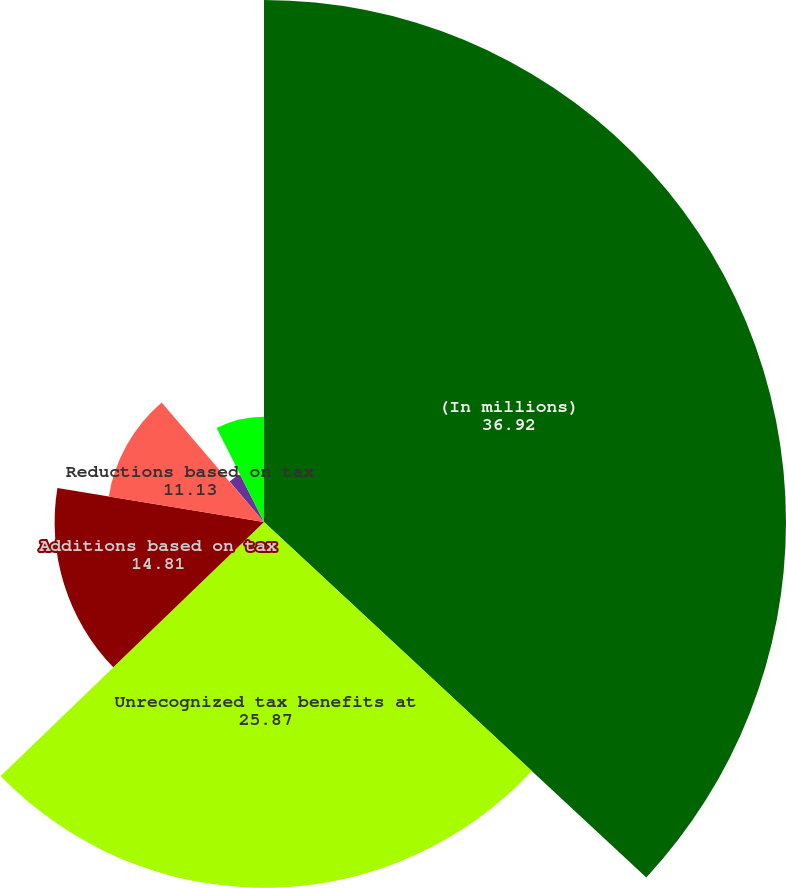Convert chart to OTSL. <chart><loc_0><loc_0><loc_500><loc_500><pie_chart><fcel>(In millions)<fcel>Unrecognized tax benefits at<fcel>Additions based on tax<fcel>Reductions based on tax<fcel>Reductions based on<fcel>Reductions based on the lapse<fcel>Exchange rate fluctuations<nl><fcel>36.92%<fcel>25.87%<fcel>14.81%<fcel>11.13%<fcel>0.07%<fcel>3.76%<fcel>7.44%<nl></chart> 